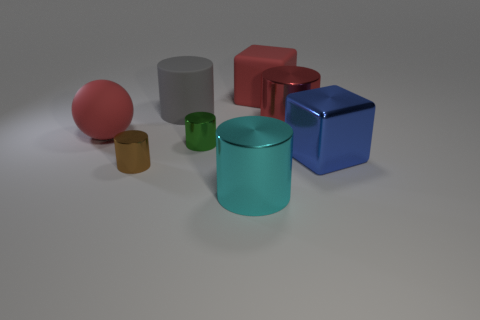Subtract all large metallic cylinders. How many cylinders are left? 3 Add 1 large red spheres. How many objects exist? 9 Subtract all gray cylinders. How many cylinders are left? 4 Subtract 3 cylinders. How many cylinders are left? 2 Subtract all brown rubber objects. Subtract all large blue objects. How many objects are left? 7 Add 5 large red matte blocks. How many large red matte blocks are left? 6 Add 8 big gray things. How many big gray things exist? 9 Subtract 0 gray cubes. How many objects are left? 8 Subtract all balls. How many objects are left? 7 Subtract all gray cylinders. Subtract all red cubes. How many cylinders are left? 4 